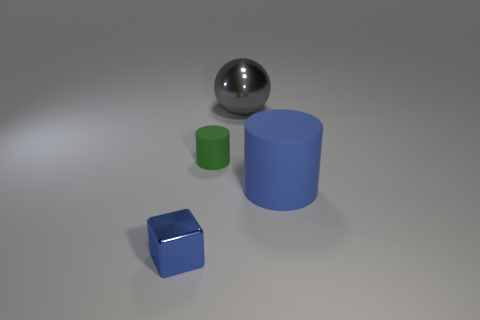Add 4 green rubber objects. How many objects exist? 8 Subtract all blocks. How many objects are left? 3 Add 4 blue rubber objects. How many blue rubber objects exist? 5 Subtract 1 blue blocks. How many objects are left? 3 Subtract all small rubber cylinders. Subtract all large metal objects. How many objects are left? 2 Add 1 blue matte objects. How many blue matte objects are left? 2 